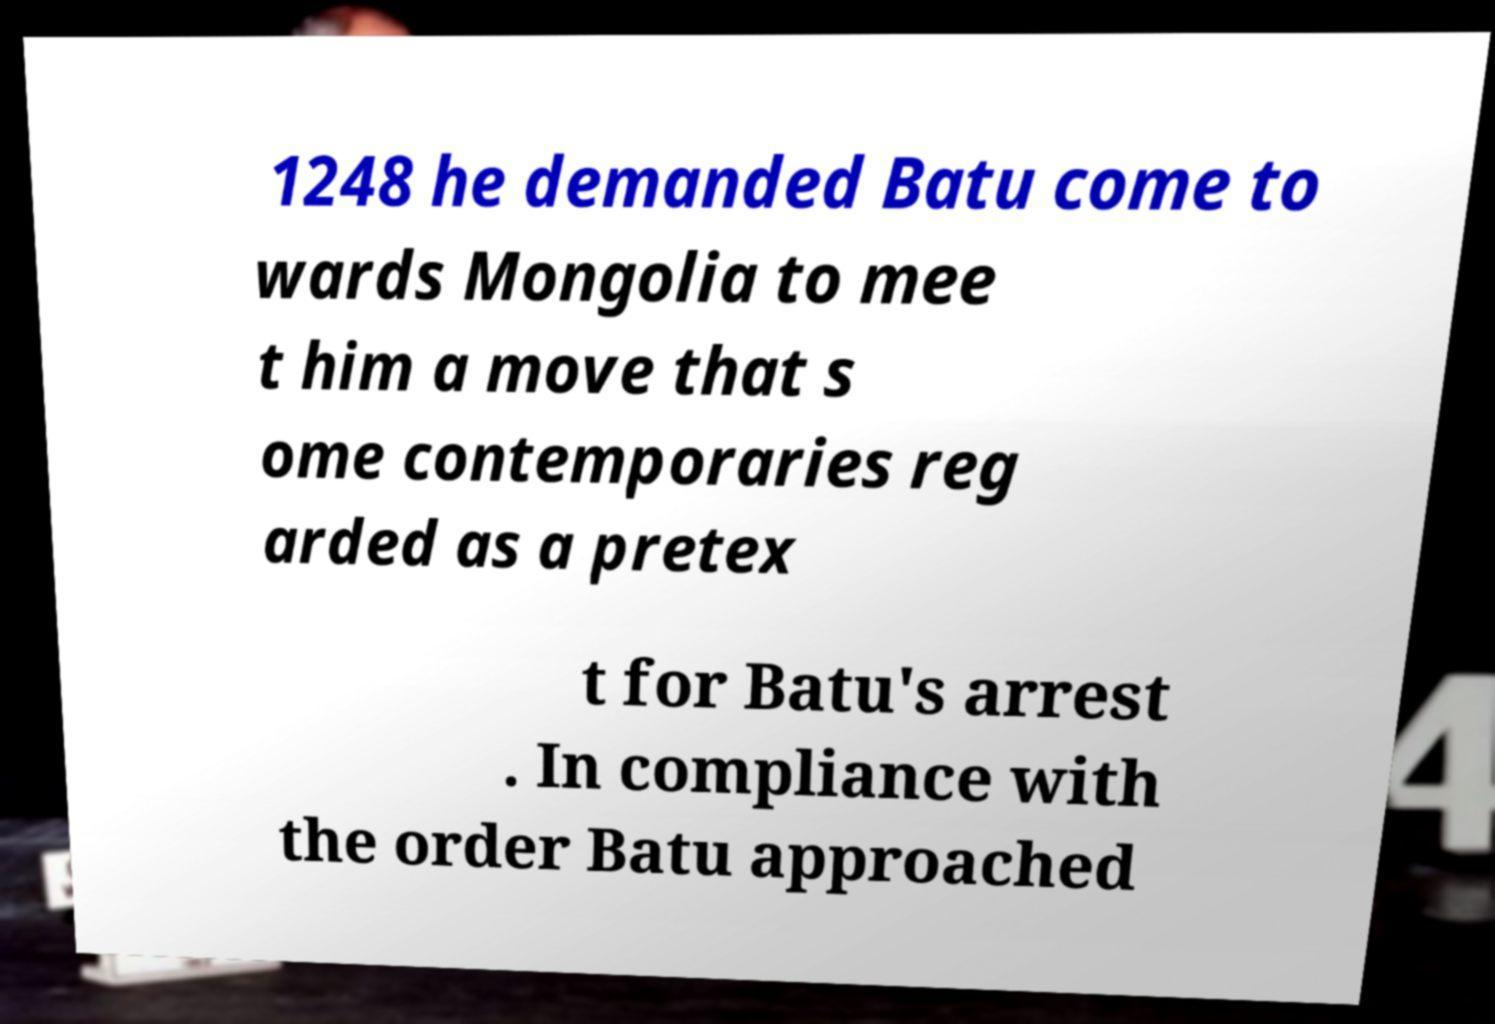For documentation purposes, I need the text within this image transcribed. Could you provide that? 1248 he demanded Batu come to wards Mongolia to mee t him a move that s ome contemporaries reg arded as a pretex t for Batu's arrest . In compliance with the order Batu approached 